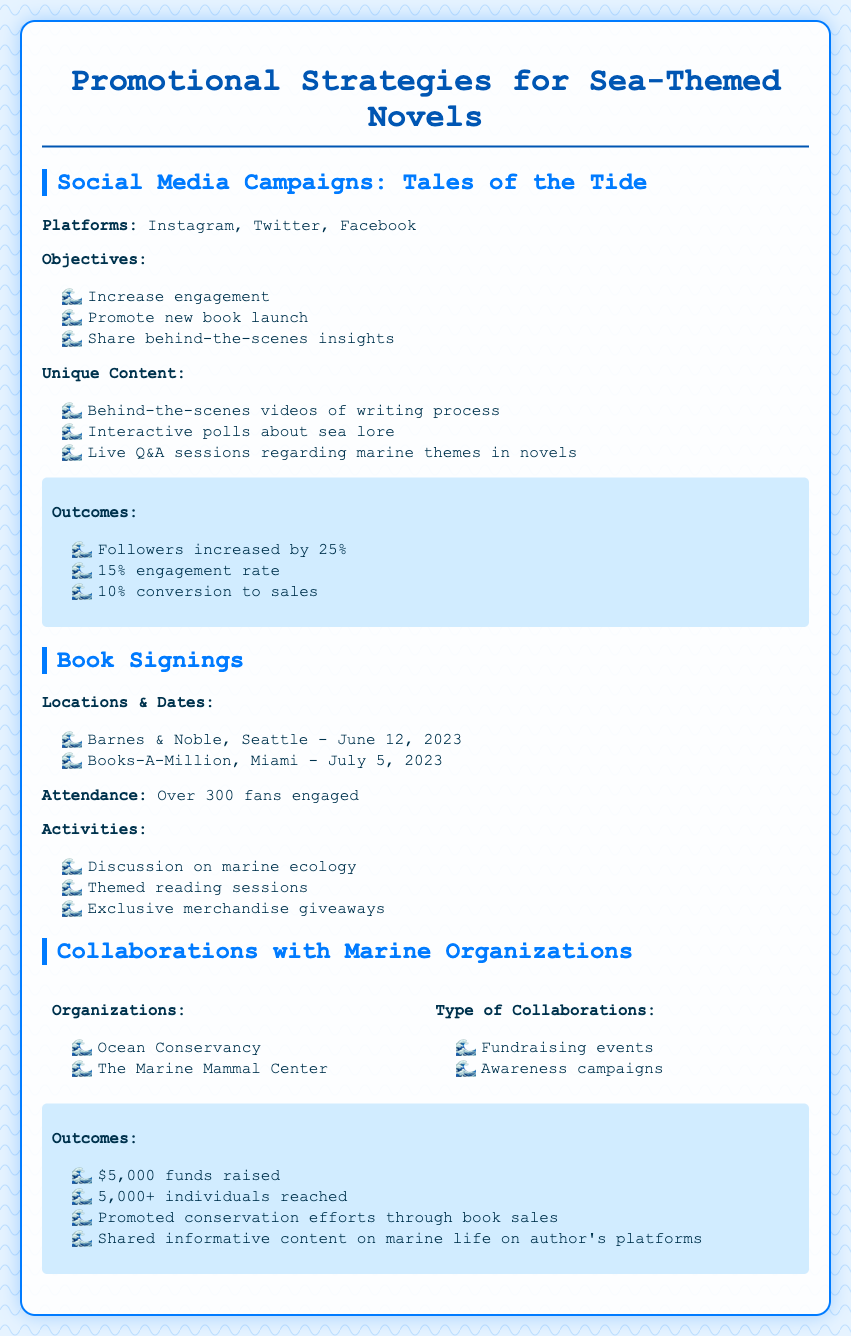What are the platforms used for social media campaigns? The platforms listed in the document for social media campaigns are Instagram, Twitter, and Facebook.
Answer: Instagram, Twitter, Facebook What was the attendance at the book signings? The document mentions that over 300 fans engaged at the book signings.
Answer: Over 300 What types of activities were included in the book signings? The activities mentioned include discussion on marine ecology, themed reading sessions, and exclusive merchandise giveaways.
Answer: Discussion on marine ecology, themed reading sessions, exclusive merchandise giveaways How much funds were raised through collaborations with marine organizations? The document states that $5,000 funds were raised through collaborations with marine organizations.
Answer: $5,000 What was the increase in followers from social media campaigns? The document specifies that followers increased by 25% as a result of social media campaigns.
Answer: 25% What unique content was shared during social media campaigns? The document mentions that behind-the-scenes videos of the writing process, interactive polls about sea lore, and live Q&A sessions were shared as unique content.
Answer: Behind-the-scenes videos, interactive polls, live Q&A sessions Name one marine organization collaborated with in the promotional strategies. The document lists Ocean Conservancy and The Marine Mammal Center as organizations collaborated with.
Answer: Ocean Conservancy What outcomes were achieved from social media campaigns? Outcomes listed include a 15% engagement rate and a 10% conversion to sales from social media campaigns.
Answer: 15% engagement rate, 10% conversion to sales 